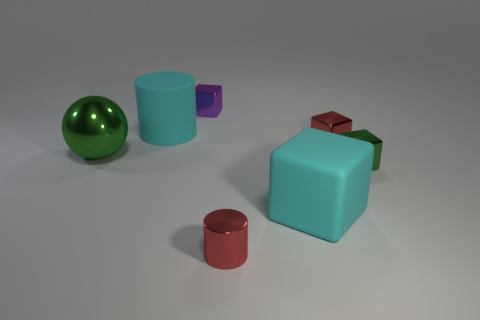Can you describe the largest object in the scene? The largest object in the scene is a light blue cube with a smooth surface. It's placed near the center and has a smaller green cube and a small red object next to it. 